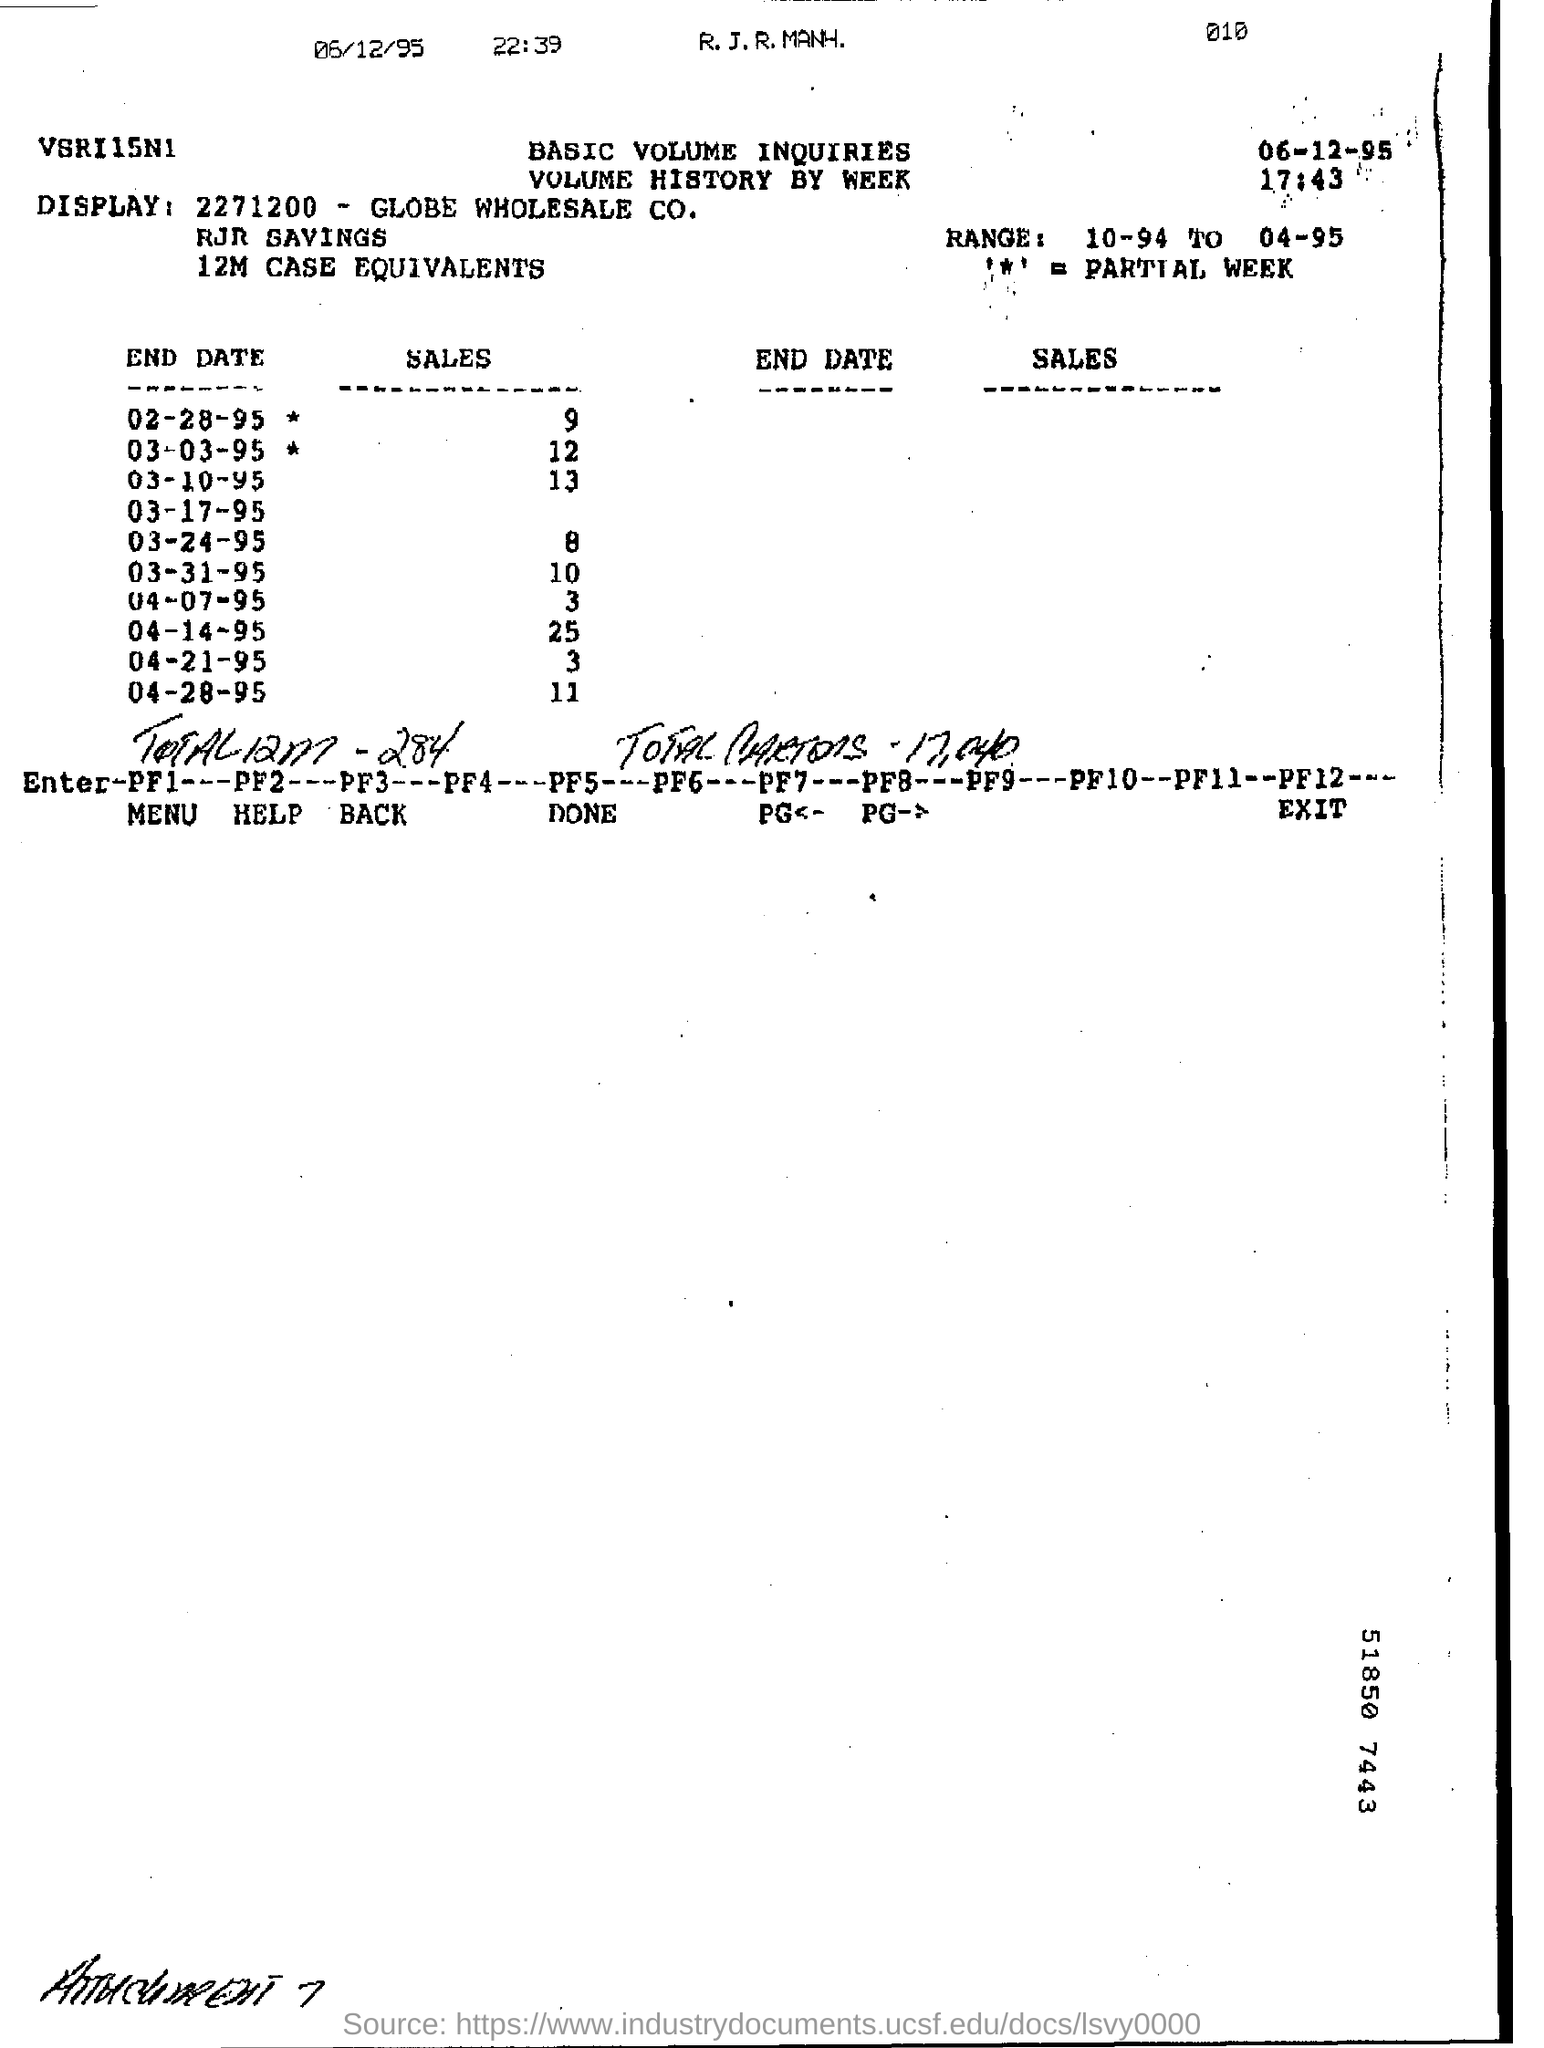Whats the sales by end of 03-03-95 *?
Keep it short and to the point. 12. Largest number of SALES  was made on?
Provide a short and direct response. 04-14-95. Whats the RANGE  mentioned?
Offer a terse response. 10-94 to 04-95. 